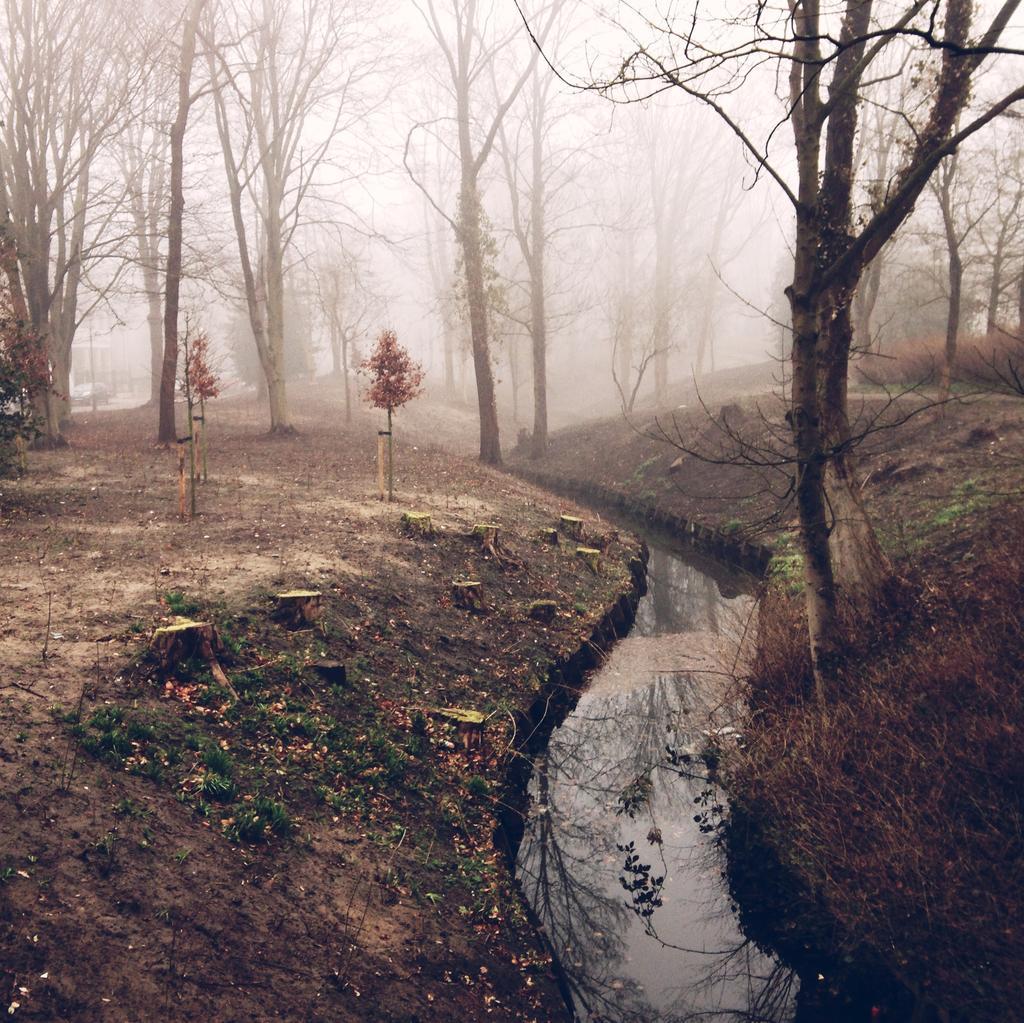In one or two sentences, can you explain what this image depicts? In this picture we can see water, beside the water we can see grass, trees and some objects and we can see sky in the background. 